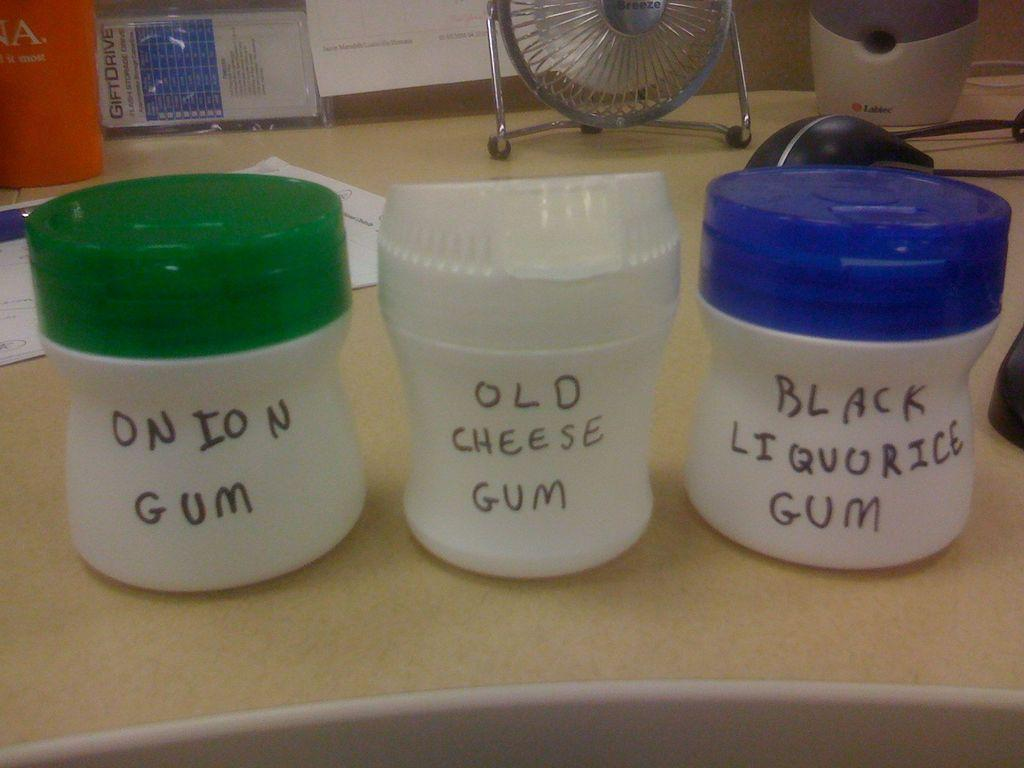<image>
Relay a brief, clear account of the picture shown. three white bottles and one with Onion Gum on it 